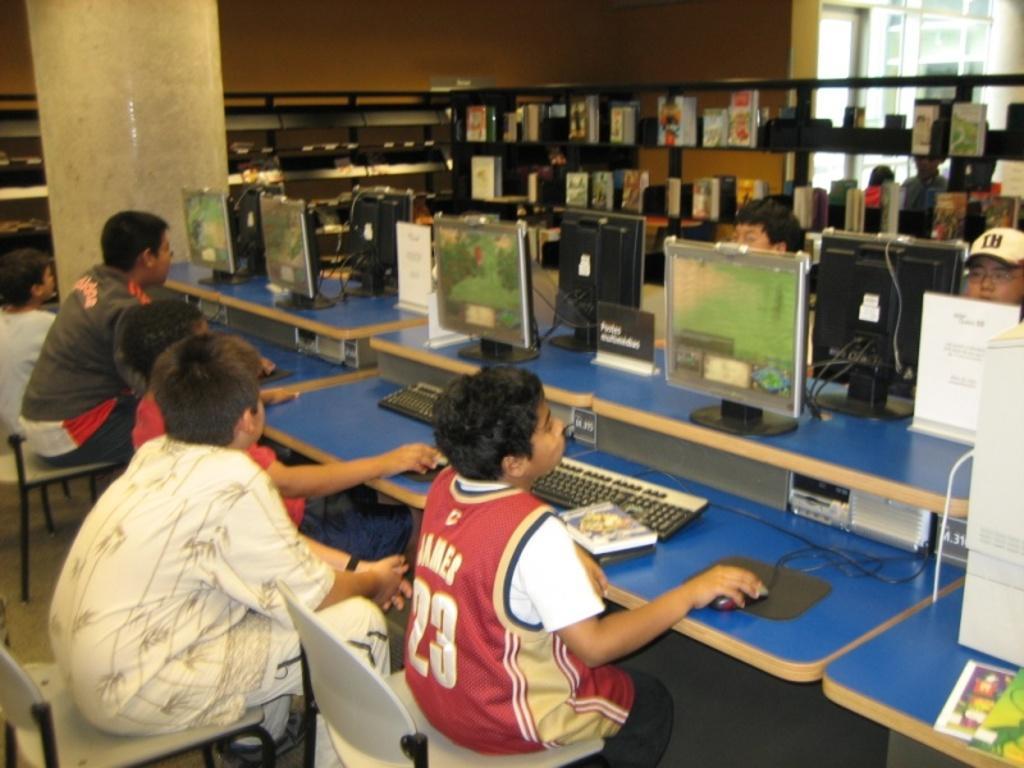Please provide a concise description of this image. These racks are filled with books. On this table there are monitors, keyboards and mouse. These persons are sitting on a chairs. These is pillar. 